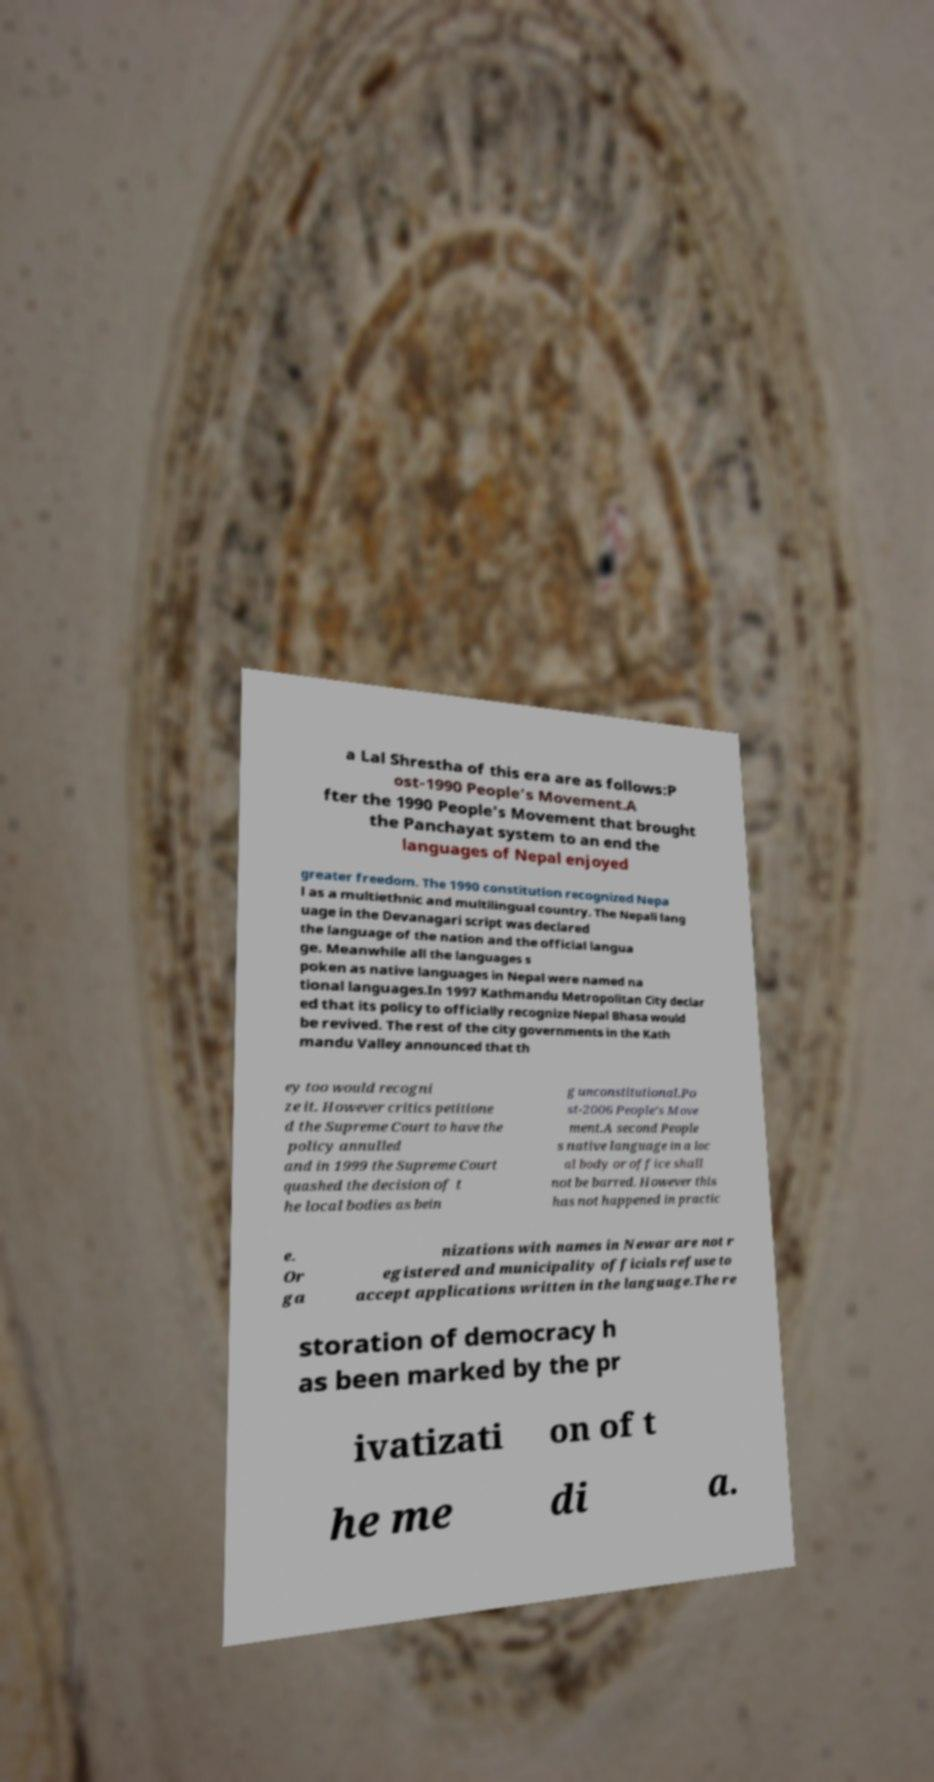Could you assist in decoding the text presented in this image and type it out clearly? a Lal Shrestha of this era are as follows:P ost-1990 People's Movement.A fter the 1990 People's Movement that brought the Panchayat system to an end the languages of Nepal enjoyed greater freedom. The 1990 constitution recognized Nepa l as a multiethnic and multilingual country. The Nepali lang uage in the Devanagari script was declared the language of the nation and the official langua ge. Meanwhile all the languages s poken as native languages in Nepal were named na tional languages.In 1997 Kathmandu Metropolitan City declar ed that its policy to officially recognize Nepal Bhasa would be revived. The rest of the city governments in the Kath mandu Valley announced that th ey too would recogni ze it. However critics petitione d the Supreme Court to have the policy annulled and in 1999 the Supreme Court quashed the decision of t he local bodies as bein g unconstitutional.Po st-2006 People's Move ment.A second People s native language in a loc al body or office shall not be barred. However this has not happened in practic e. Or ga nizations with names in Newar are not r egistered and municipality officials refuse to accept applications written in the language.The re storation of democracy h as been marked by the pr ivatizati on of t he me di a. 